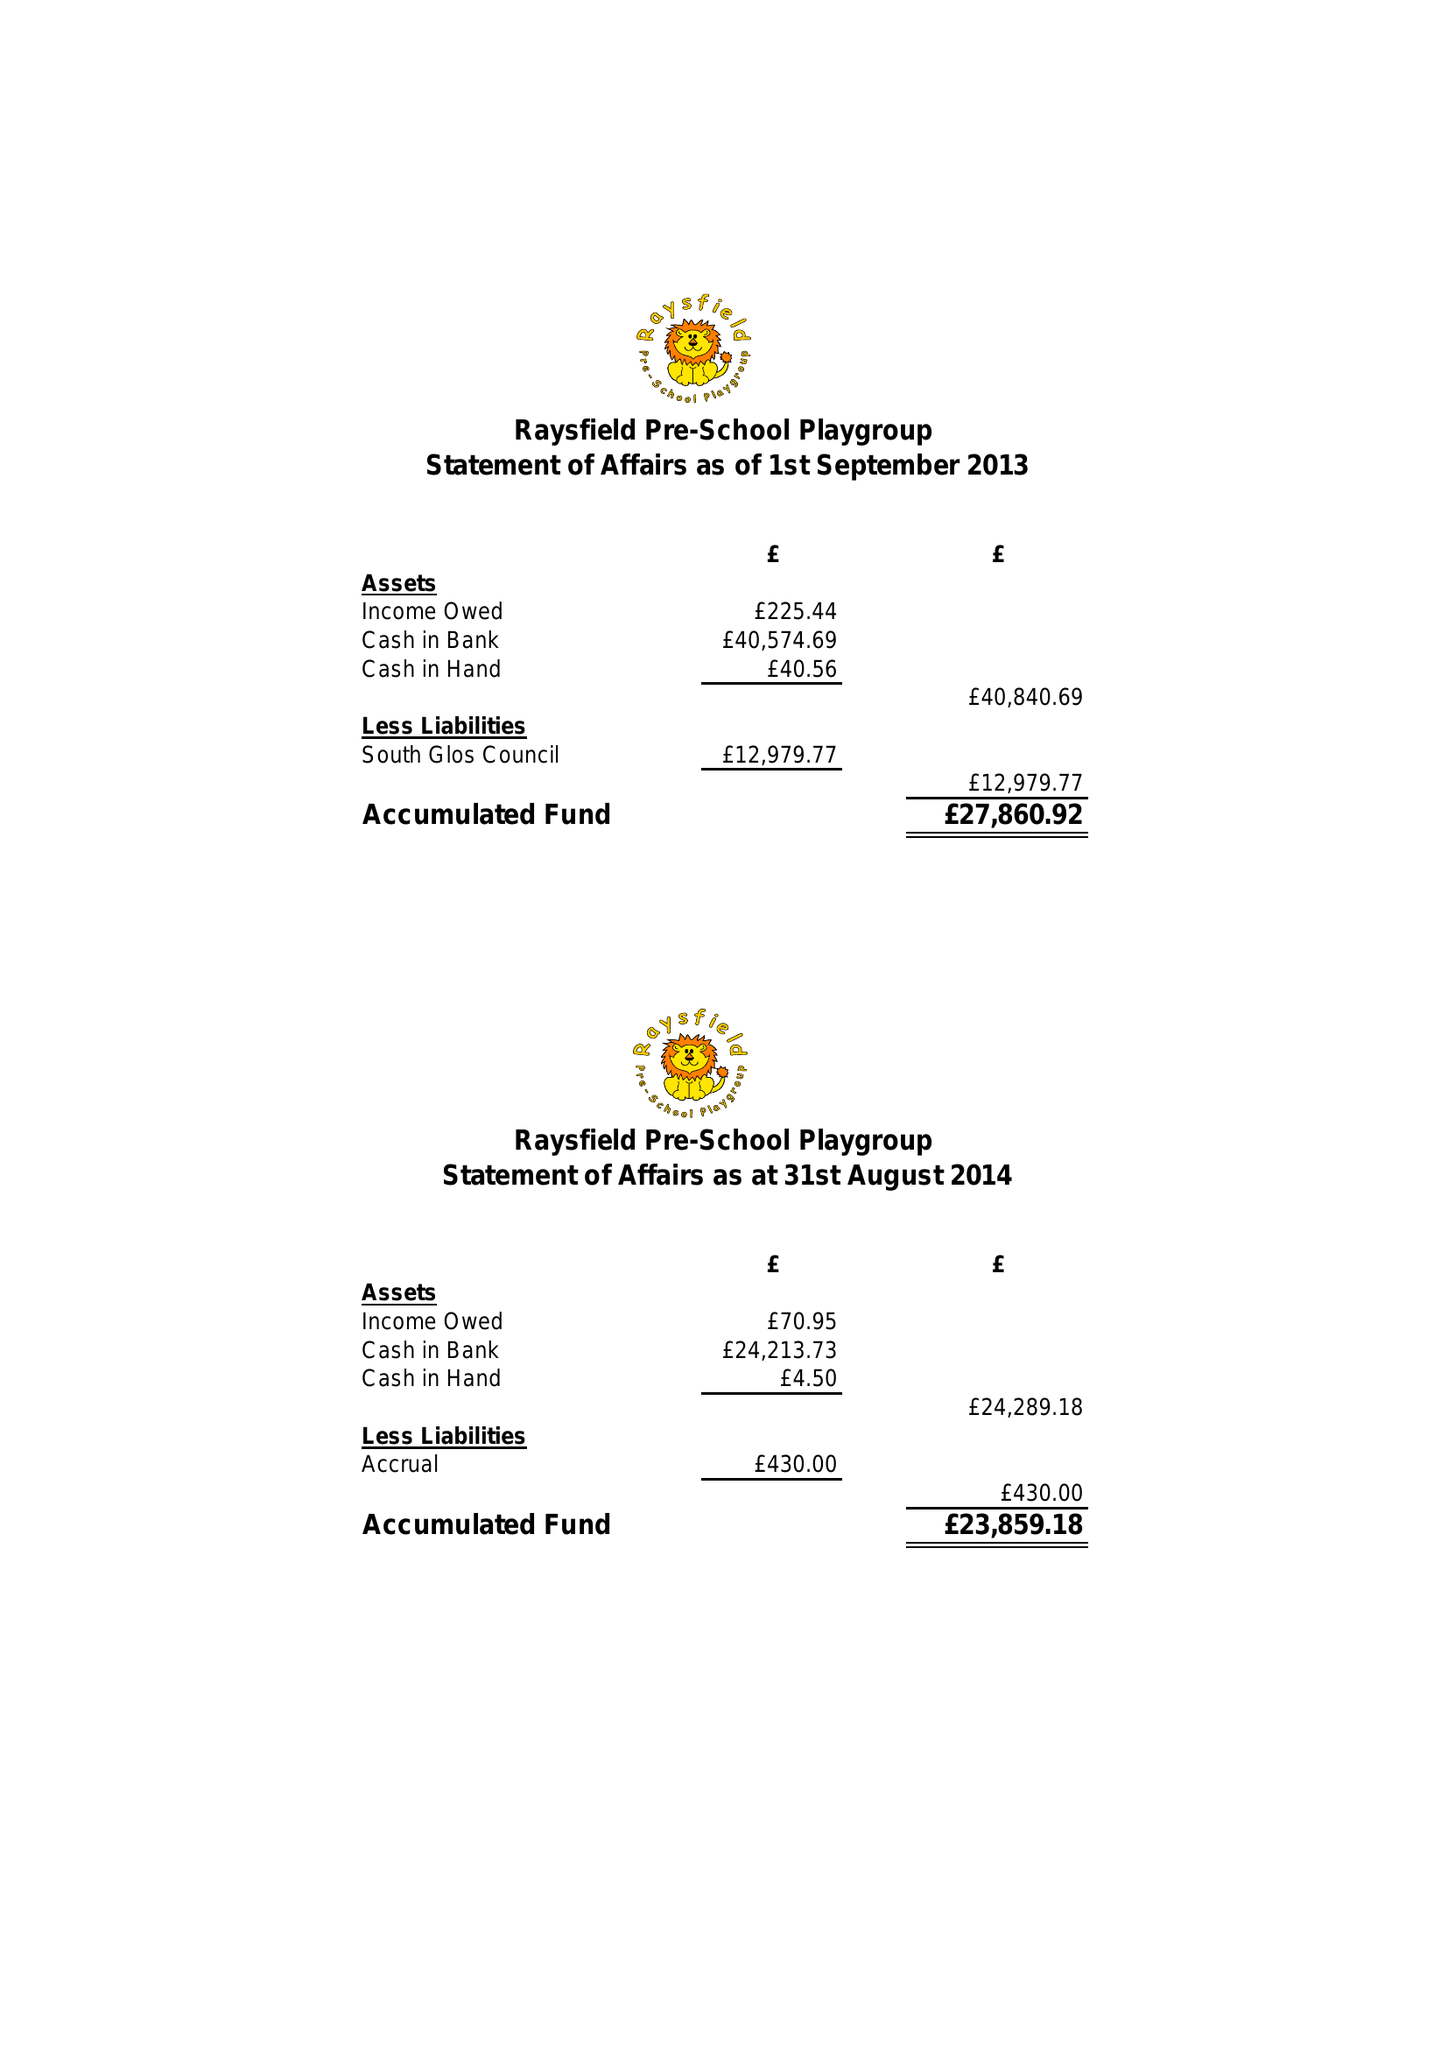What is the value for the address__postcode?
Answer the question using a single word or phrase. BS37 6JZ 